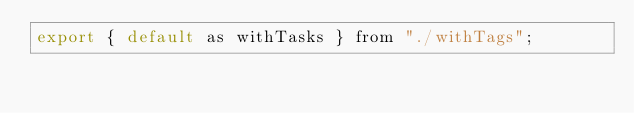Convert code to text. <code><loc_0><loc_0><loc_500><loc_500><_JavaScript_>export { default as withTasks } from "./withTags";
</code> 